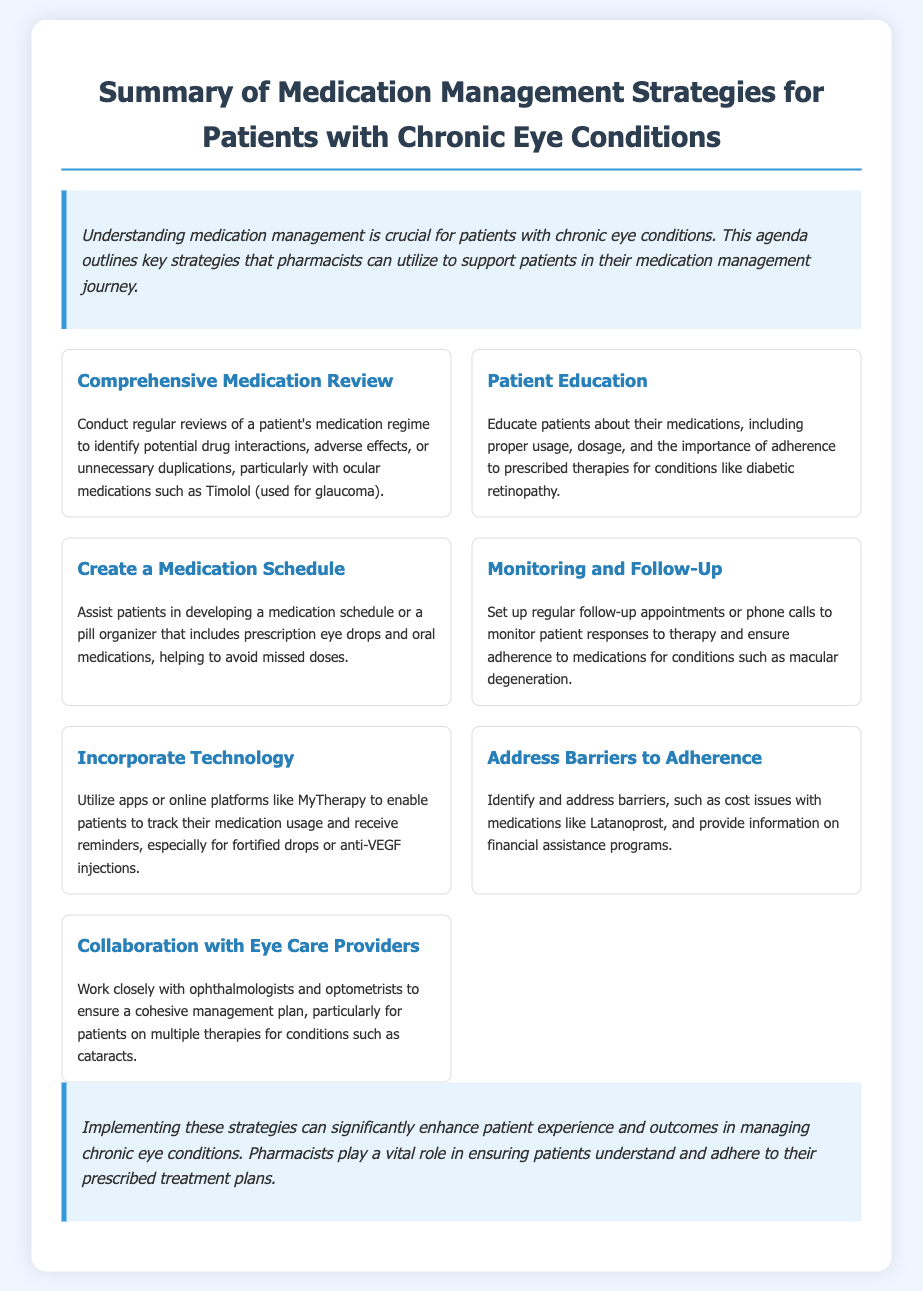what is the title of the document? The title is stated at the top of the document, summarizing its content.
Answer: Summary of Medication Management Strategies for Patients with Chronic Eye Conditions what is one strategy for patient education? The strategy discusses educating patients about medications, highlighting the importance of this practice.
Answer: Proper usage, dosage, and the importance of adherence which medication is specifically mentioned for glaucoma? The document identifies a particular medication used for glaucoma within the context of medication management.
Answer: Timolol what should patients create to avoid missed doses? The document suggests a specific tool that can help in managing medication adherence effectively.
Answer: A medication schedule how often should follow-up appointments occur? The document indicates the need for regular follow-up to ensure medication adherence and monitor therapy responses.
Answer: Regularly which technology can aid patients in tracking their medication usage? The document names a specific type of tool that can assist in medication management for patients.
Answer: Apps or online platforms like MyTherapy what is a barrier to adherence mentioned in the document? The document highlights specific issues that may prevent patients from adhering to their medication regimen.
Answer: Cost issues who should pharmacists collaborate with for patient management? The document emphasizes collaboration in managing patient care, naming specific professionals.
Answer: Ophthalmologists and optometrists 